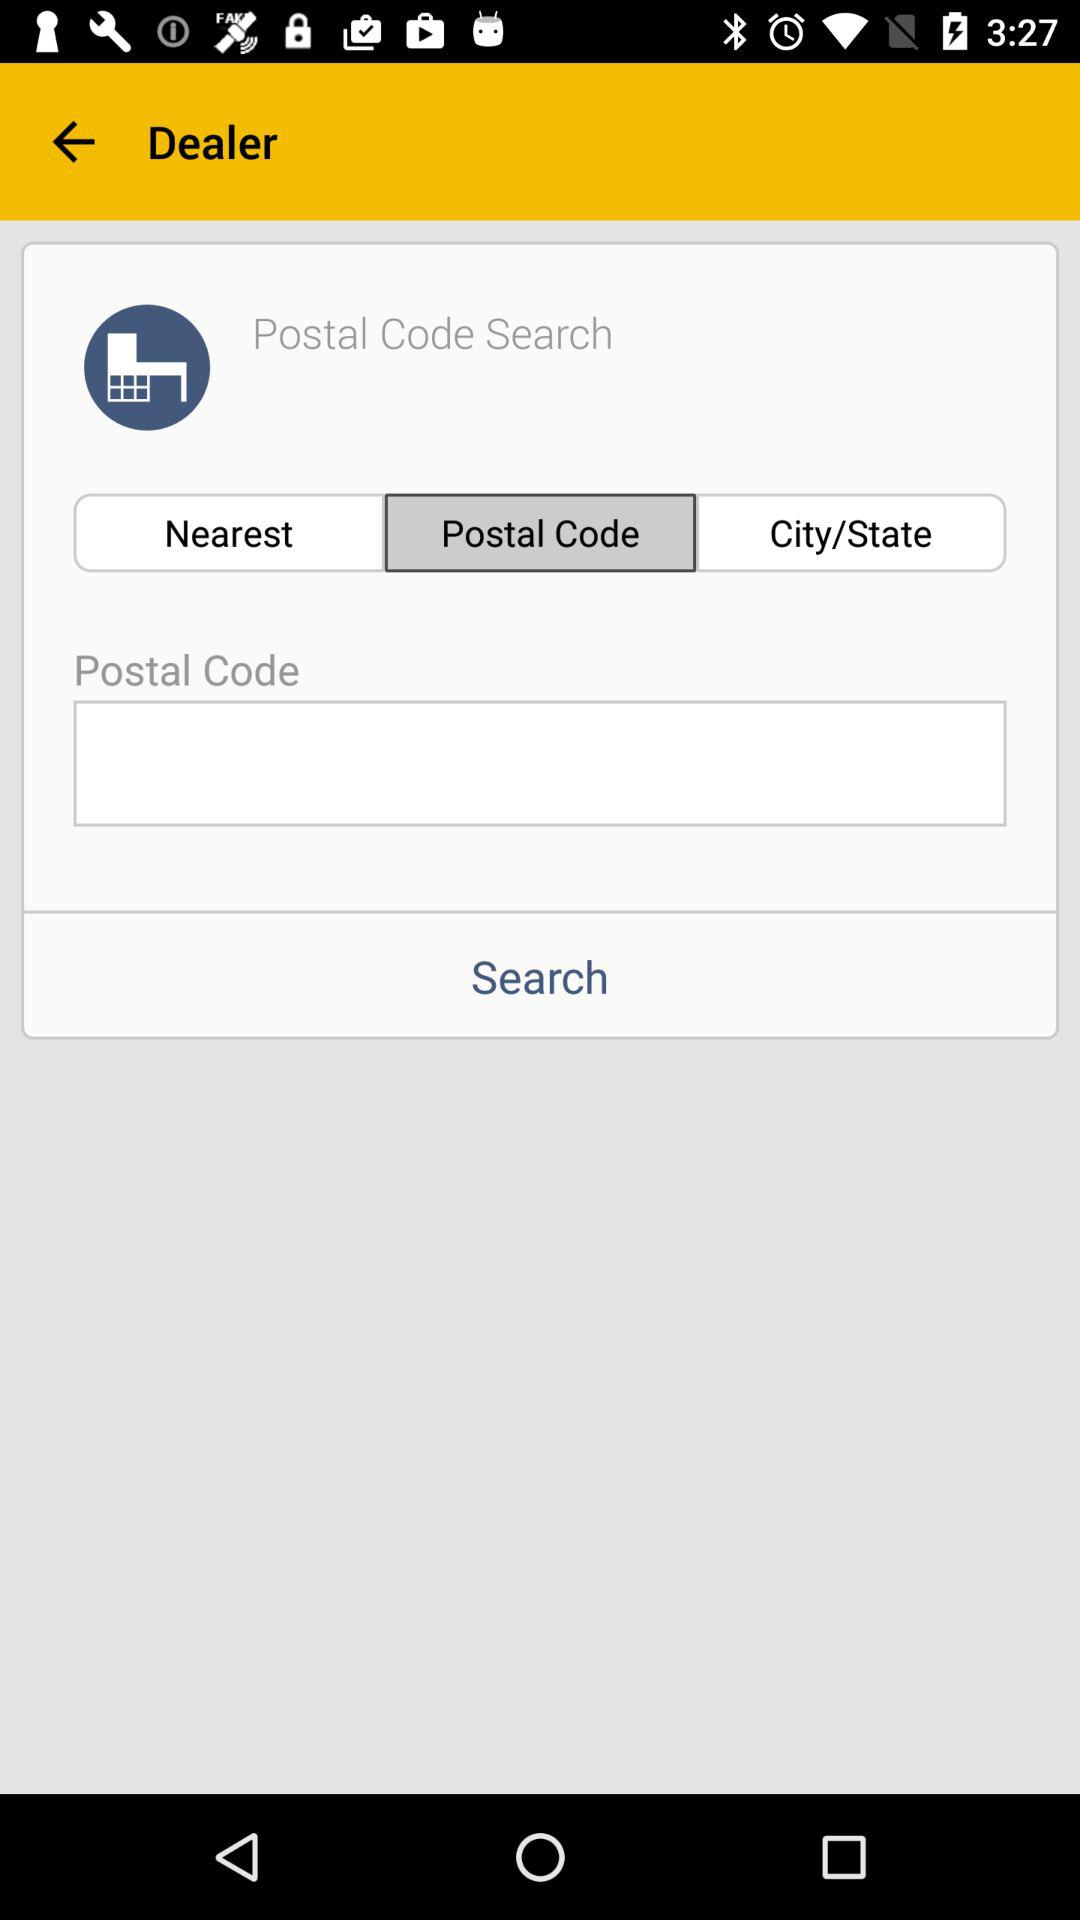Which tab is selected? The selected tab is "Postal Code". 